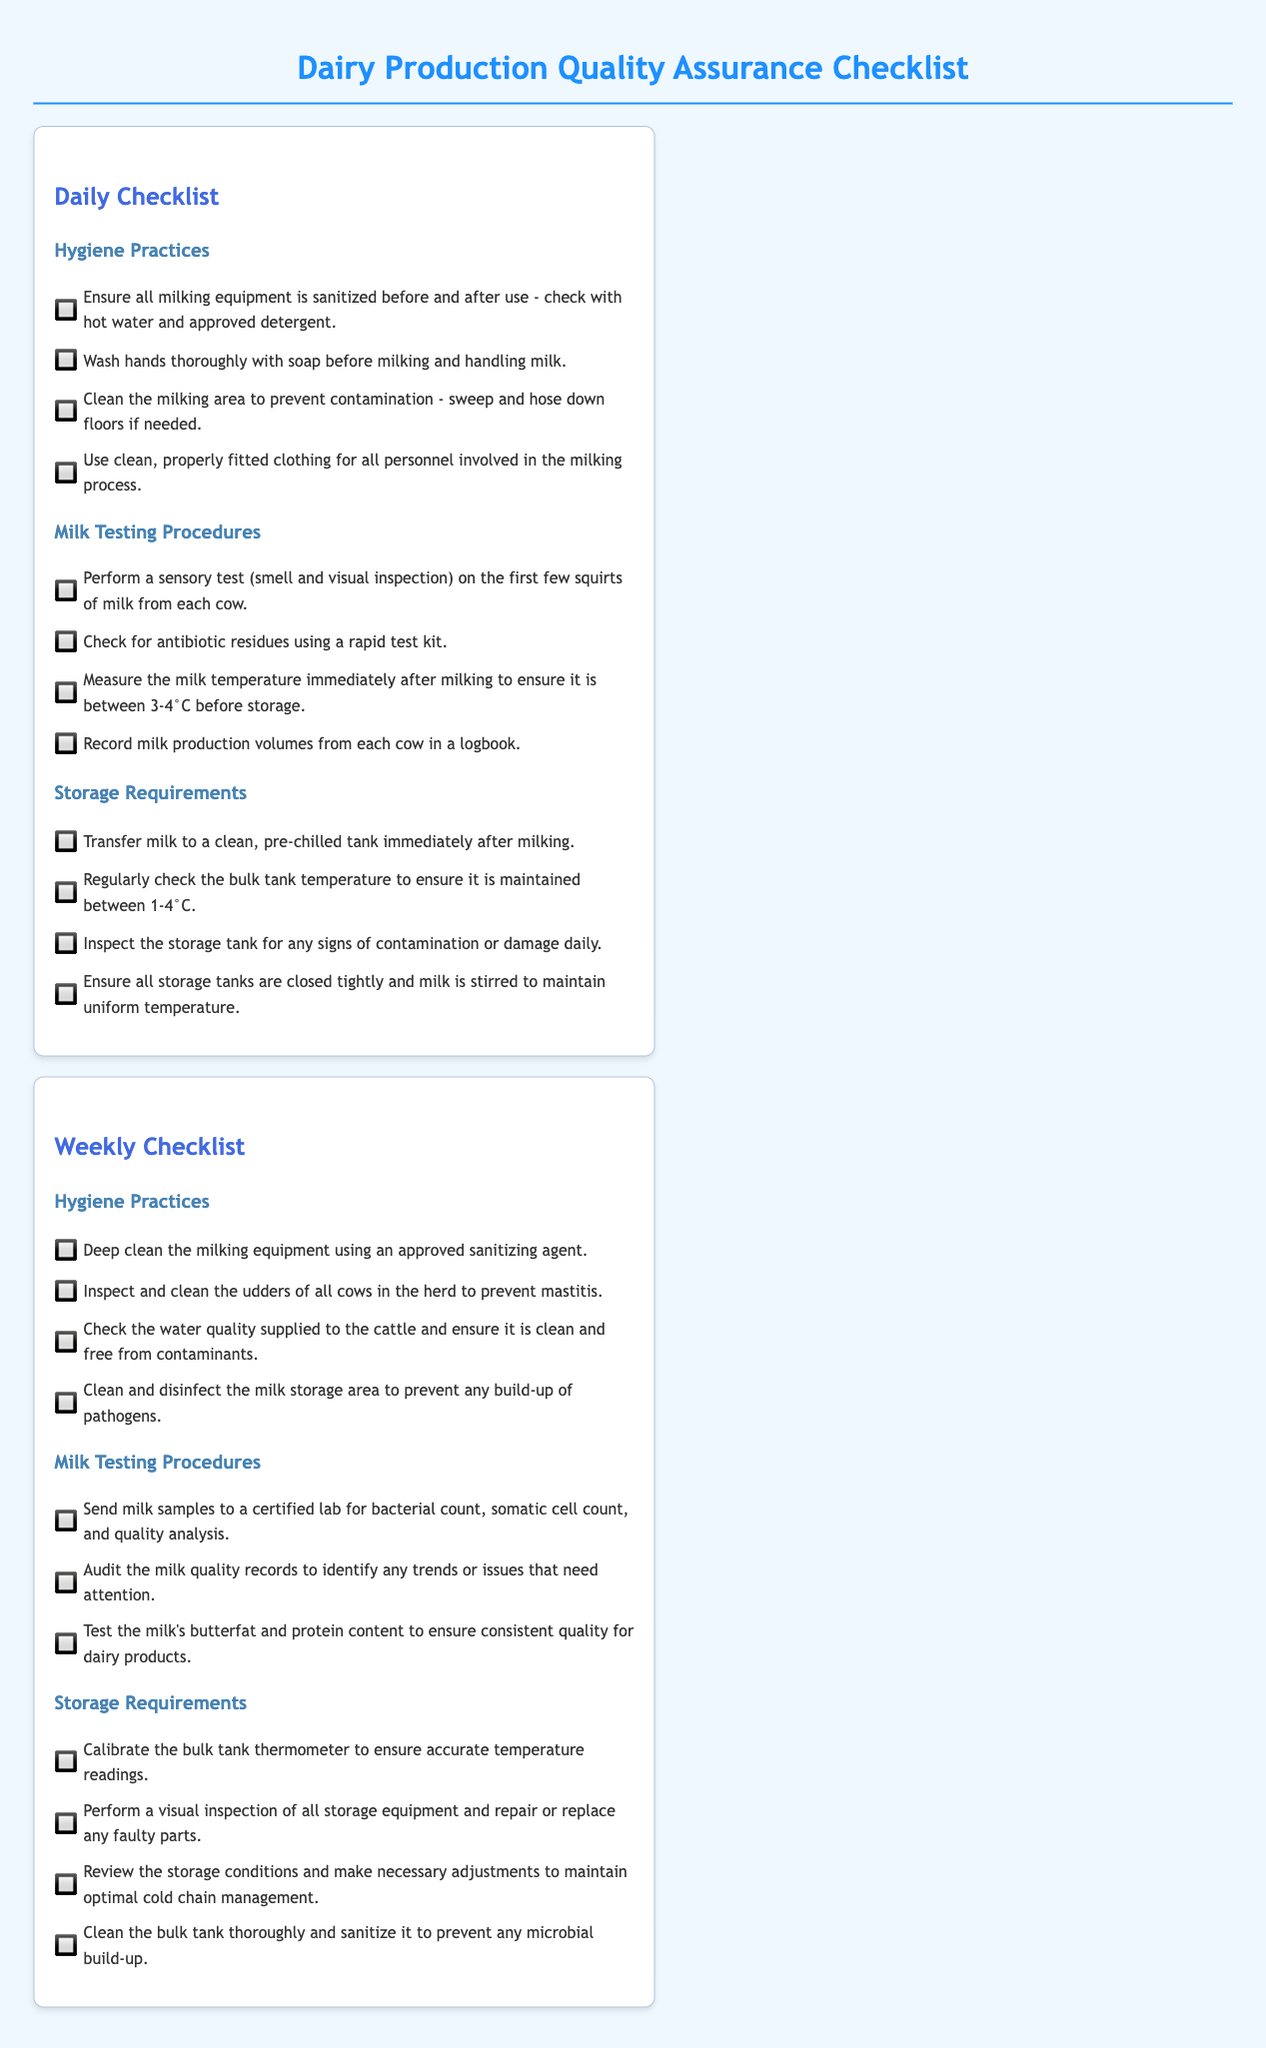what is the maximum temperature to store milk? The document states that the milk temperature before storage should be between 3-4°C.
Answer: 4°C how often should milking equipment be deep cleaned? The weekly checklist specifies a deep clean of the milking equipment using an approved sanitizing agent.
Answer: Weekly what should be checked in milk testing procedures daily? The daily checklist indicates checking for antibiotic residues using a rapid test kit.
Answer: Antibiotic residues what is the specific temperature range for the bulk tank? The checklist mentions maintaining the bulk tank temperature between 1-4°C.
Answer: 1-4°C how often should milk samples be sent for bacterial count? The weekly checklist instructs to send milk samples to a certified lab for analysis.
Answer: Weekly what should personnel wear during milking? The daily checklist mentions using clean, properly fitted clothing for all personnel involved.
Answer: Clean clothing which document section mentions cleaning the milk storage area? The weekly checklist includes cleaning and disinfecting the milk storage area.
Answer: Weekly checklist what is the first step in hygiene practices before milking? The daily checklist states washing hands thoroughly with soap before milking.
Answer: Wash hands how often should you inspect water quality for cattle? The weekly checklist requires checking the water quality supplied to the cattle.
Answer: Weekly 